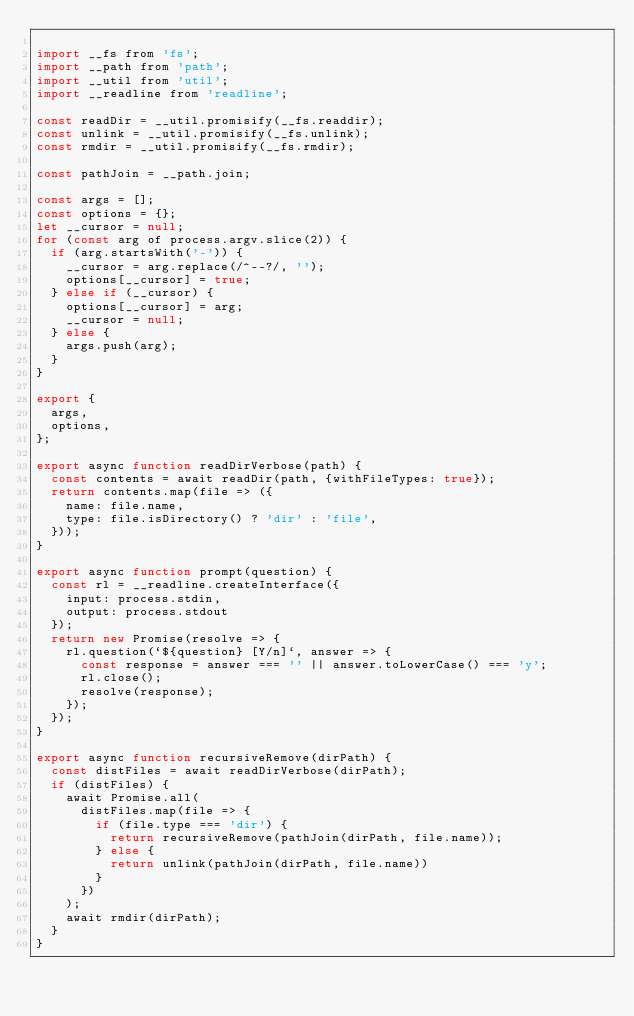<code> <loc_0><loc_0><loc_500><loc_500><_JavaScript_>
import __fs from 'fs';
import __path from 'path';
import __util from 'util';
import __readline from 'readline';

const readDir = __util.promisify(__fs.readdir);
const unlink = __util.promisify(__fs.unlink);
const rmdir = __util.promisify(__fs.rmdir);

const pathJoin = __path.join;

const args = [];
const options = {};
let __cursor = null;
for (const arg of process.argv.slice(2)) {
  if (arg.startsWith('-')) {
    __cursor = arg.replace(/^--?/, '');
    options[__cursor] = true;
  } else if (__cursor) {
    options[__cursor] = arg;
    __cursor = null;
  } else {
    args.push(arg);
  }
}

export {
  args,
  options,
};

export async function readDirVerbose(path) {
  const contents = await readDir(path, {withFileTypes: true});
  return contents.map(file => ({
    name: file.name,
    type: file.isDirectory() ? 'dir' : 'file',
  }));
}

export async function prompt(question) {
  const rl = __readline.createInterface({
    input: process.stdin,
    output: process.stdout
  });
  return new Promise(resolve => {
    rl.question(`${question} [Y/n]`, answer => {
      const response = answer === '' || answer.toLowerCase() === 'y';
      rl.close();
      resolve(response);
    });
  });
}

export async function recursiveRemove(dirPath) {
  const distFiles = await readDirVerbose(dirPath);
  if (distFiles) {
    await Promise.all(
      distFiles.map(file => {
        if (file.type === 'dir') {
          return recursiveRemove(pathJoin(dirPath, file.name));
        } else { 
          return unlink(pathJoin(dirPath, file.name))
        }
      })
    );
    await rmdir(dirPath);
  }
}
</code> 